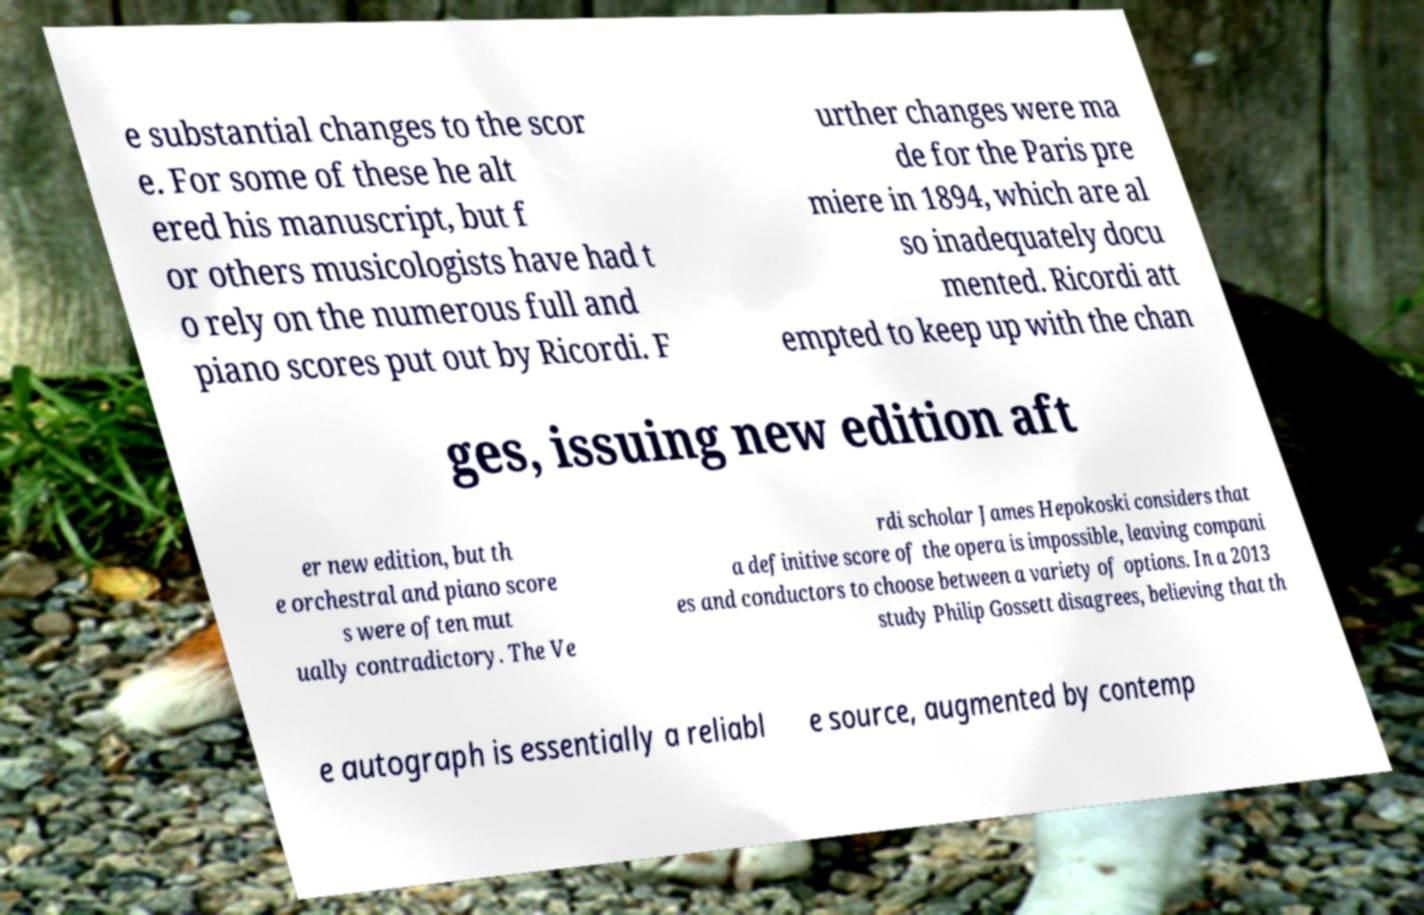Can you read and provide the text displayed in the image?This photo seems to have some interesting text. Can you extract and type it out for me? e substantial changes to the scor e. For some of these he alt ered his manuscript, but f or others musicologists have had t o rely on the numerous full and piano scores put out by Ricordi. F urther changes were ma de for the Paris pre miere in 1894, which are al so inadequately docu mented. Ricordi att empted to keep up with the chan ges, issuing new edition aft er new edition, but th e orchestral and piano score s were often mut ually contradictory. The Ve rdi scholar James Hepokoski considers that a definitive score of the opera is impossible, leaving compani es and conductors to choose between a variety of options. In a 2013 study Philip Gossett disagrees, believing that th e autograph is essentially a reliabl e source, augmented by contemp 